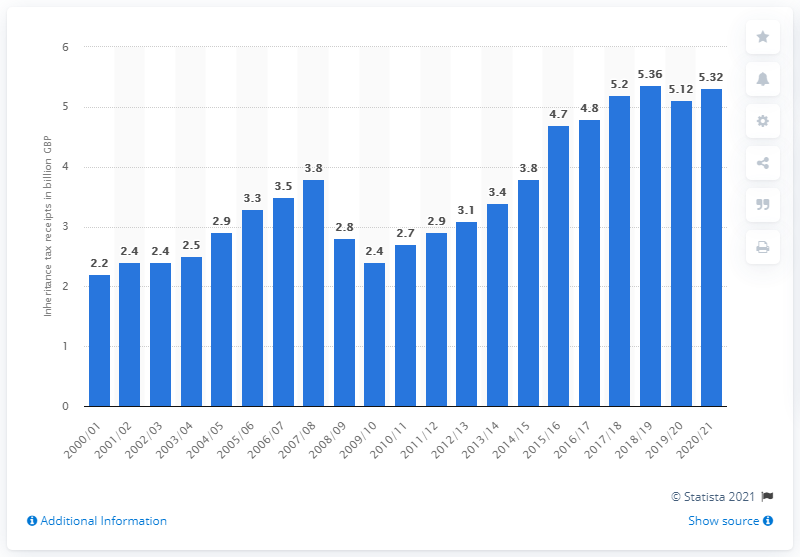Give some essential details in this illustration. In the previous financial year, the highest amount of inheritance tax receipts in the UK was 5.32 billion pounds. 